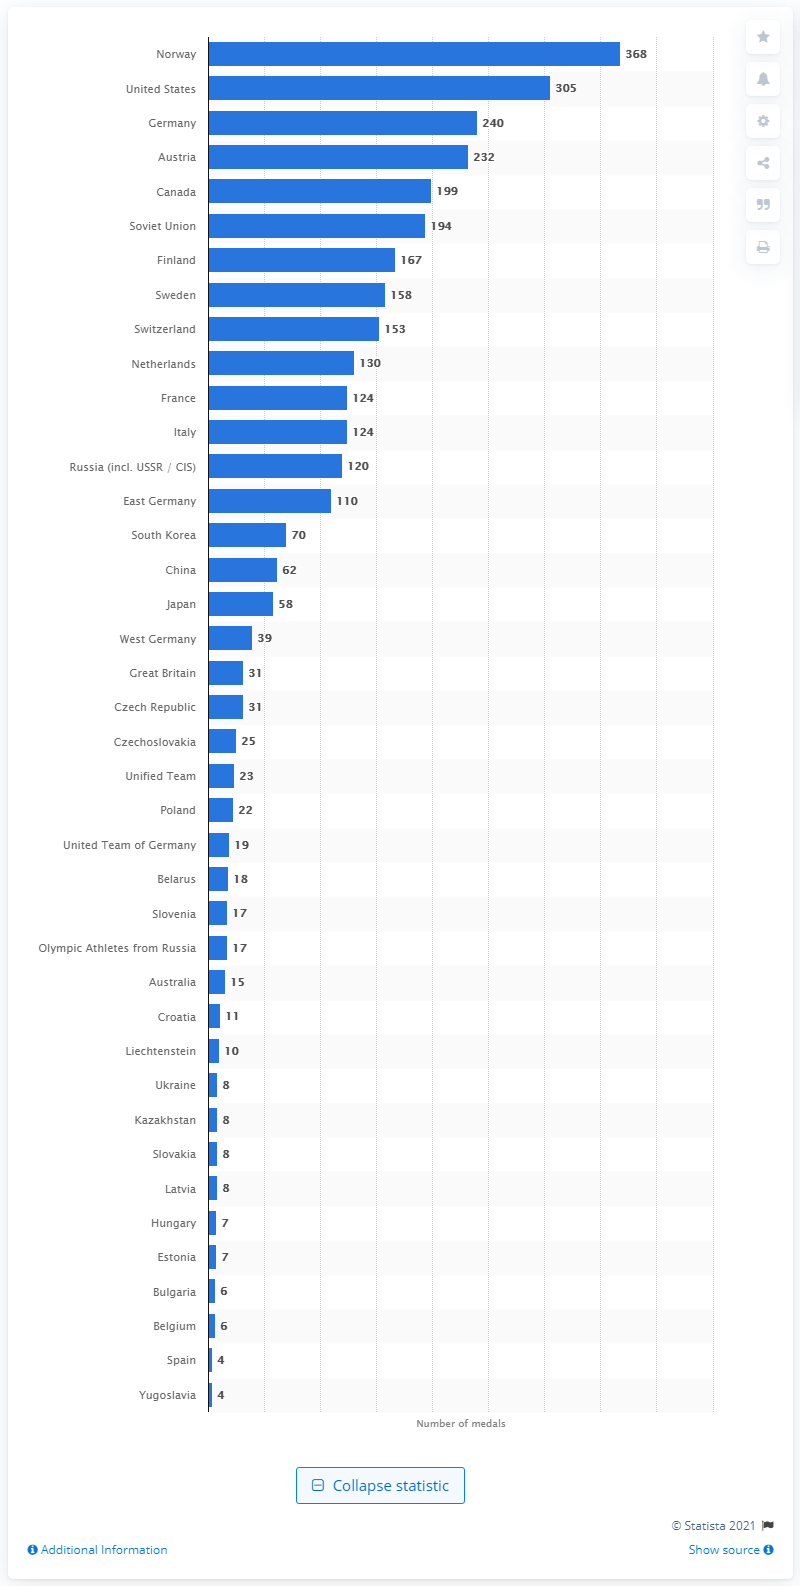Identify some key points in this picture. In the 2018 Winter Olympics, athletes from the United States won a total of 305 medals. 